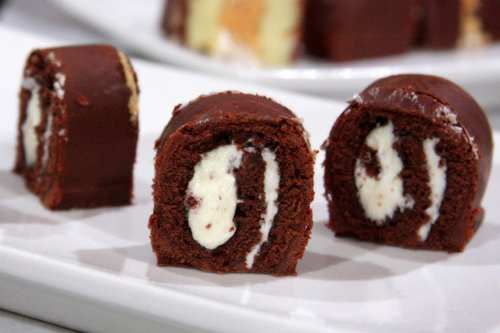<image>
Is the plate under the dessert? Yes. The plate is positioned underneath the dessert, with the dessert above it in the vertical space. 